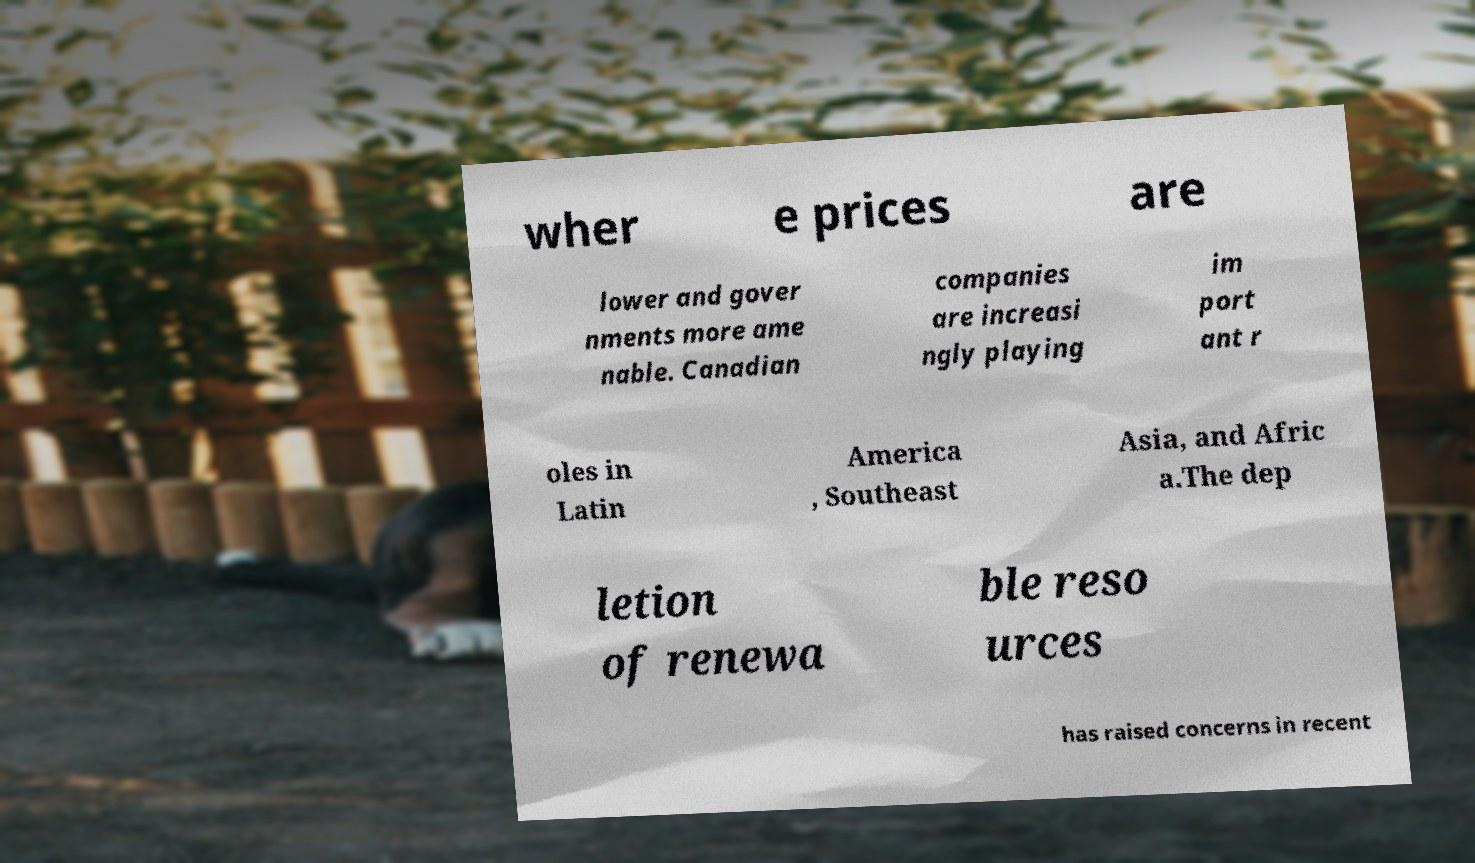Could you assist in decoding the text presented in this image and type it out clearly? wher e prices are lower and gover nments more ame nable. Canadian companies are increasi ngly playing im port ant r oles in Latin America , Southeast Asia, and Afric a.The dep letion of renewa ble reso urces has raised concerns in recent 